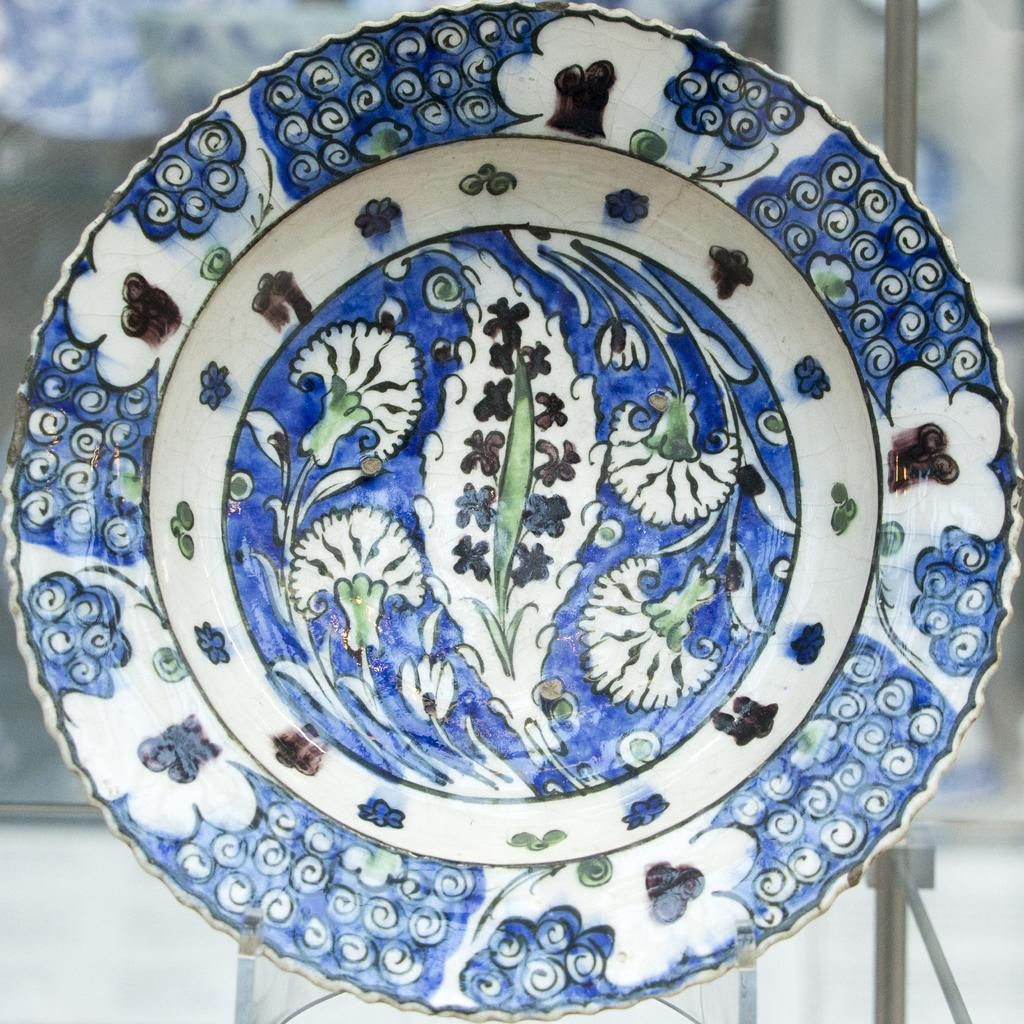What is present on the glass table in the image? There is a plate on the glass table in the image. What can be observed about the plate's design? The plate has a design on it. What type of alarm can be heard going off in the image? There is no alarm present or audible in the image. Can you see a toad sitting on the plate in the image? There is no toad present on the plate or in the image. 